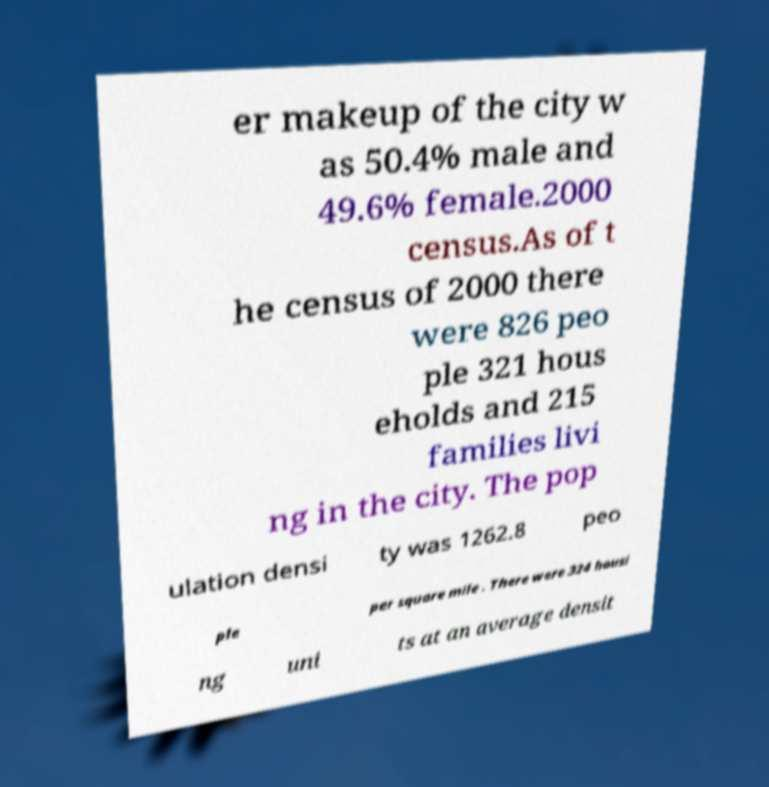Please identify and transcribe the text found in this image. er makeup of the city w as 50.4% male and 49.6% female.2000 census.As of t he census of 2000 there were 826 peo ple 321 hous eholds and 215 families livi ng in the city. The pop ulation densi ty was 1262.8 peo ple per square mile . There were 324 housi ng uni ts at an average densit 